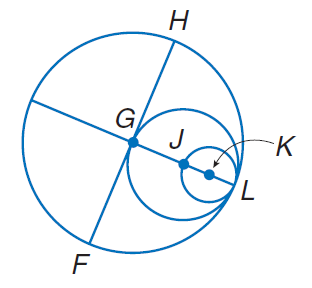Answer the mathemtical geometry problem and directly provide the correct option letter.
Question: Circles G, J, and K all intersect at L. If G H = 10, find J K.
Choices: A: 2.5 B: 5 C: 10 D: 15 A 